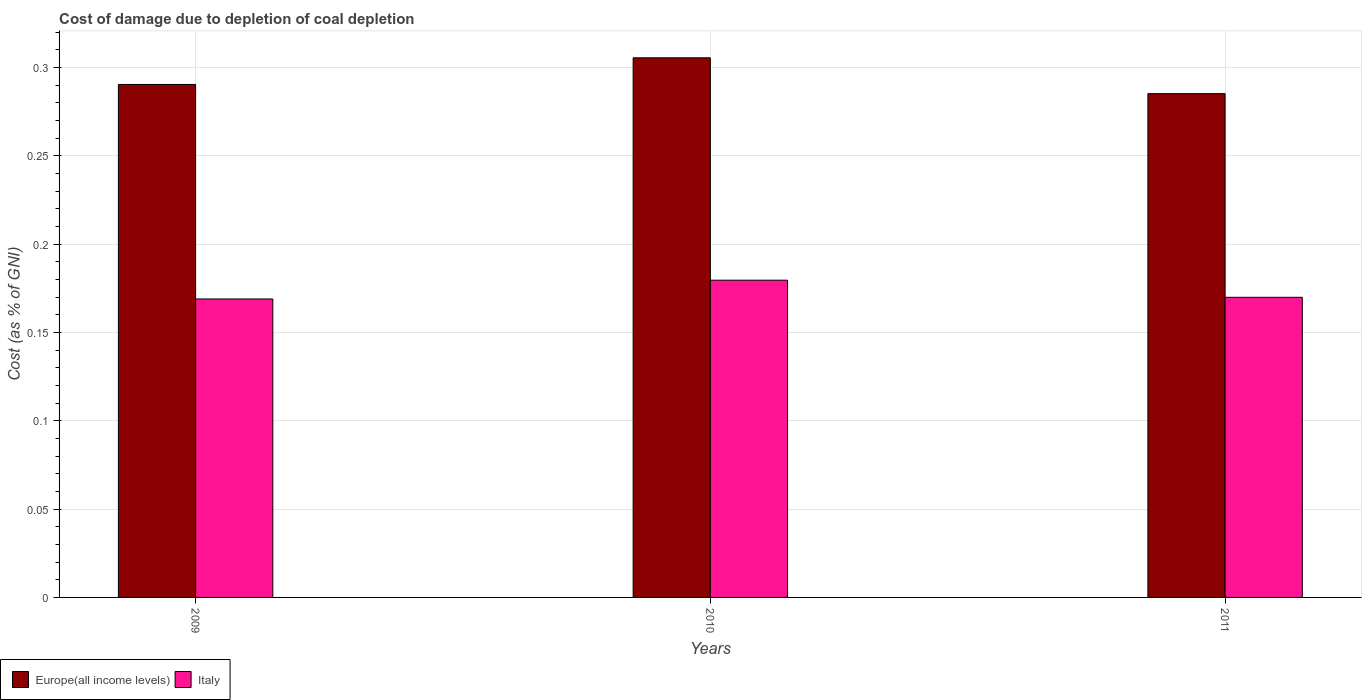How many different coloured bars are there?
Provide a succinct answer. 2. How many groups of bars are there?
Your answer should be very brief. 3. Are the number of bars on each tick of the X-axis equal?
Make the answer very short. Yes. How many bars are there on the 3rd tick from the left?
Offer a terse response. 2. What is the cost of damage caused due to coal depletion in Italy in 2011?
Your response must be concise. 0.17. Across all years, what is the maximum cost of damage caused due to coal depletion in Europe(all income levels)?
Offer a very short reply. 0.31. Across all years, what is the minimum cost of damage caused due to coal depletion in Europe(all income levels)?
Make the answer very short. 0.29. In which year was the cost of damage caused due to coal depletion in Europe(all income levels) minimum?
Your answer should be compact. 2011. What is the total cost of damage caused due to coal depletion in Europe(all income levels) in the graph?
Keep it short and to the point. 0.88. What is the difference between the cost of damage caused due to coal depletion in Europe(all income levels) in 2010 and that in 2011?
Your answer should be very brief. 0.02. What is the difference between the cost of damage caused due to coal depletion in Italy in 2010 and the cost of damage caused due to coal depletion in Europe(all income levels) in 2009?
Provide a succinct answer. -0.11. What is the average cost of damage caused due to coal depletion in Italy per year?
Provide a succinct answer. 0.17. In the year 2009, what is the difference between the cost of damage caused due to coal depletion in Italy and cost of damage caused due to coal depletion in Europe(all income levels)?
Keep it short and to the point. -0.12. What is the ratio of the cost of damage caused due to coal depletion in Italy in 2009 to that in 2010?
Provide a short and direct response. 0.94. What is the difference between the highest and the second highest cost of damage caused due to coal depletion in Europe(all income levels)?
Your answer should be very brief. 0.02. What is the difference between the highest and the lowest cost of damage caused due to coal depletion in Italy?
Make the answer very short. 0.01. In how many years, is the cost of damage caused due to coal depletion in Europe(all income levels) greater than the average cost of damage caused due to coal depletion in Europe(all income levels) taken over all years?
Give a very brief answer. 1. What does the 1st bar from the left in 2010 represents?
Give a very brief answer. Europe(all income levels). What does the 1st bar from the right in 2009 represents?
Your response must be concise. Italy. How many bars are there?
Offer a very short reply. 6. Are all the bars in the graph horizontal?
Give a very brief answer. No. How many years are there in the graph?
Offer a very short reply. 3. Does the graph contain grids?
Offer a very short reply. Yes. How many legend labels are there?
Make the answer very short. 2. How are the legend labels stacked?
Make the answer very short. Horizontal. What is the title of the graph?
Ensure brevity in your answer.  Cost of damage due to depletion of coal depletion. Does "Swaziland" appear as one of the legend labels in the graph?
Provide a succinct answer. No. What is the label or title of the X-axis?
Ensure brevity in your answer.  Years. What is the label or title of the Y-axis?
Your response must be concise. Cost (as % of GNI). What is the Cost (as % of GNI) of Europe(all income levels) in 2009?
Give a very brief answer. 0.29. What is the Cost (as % of GNI) in Italy in 2009?
Provide a short and direct response. 0.17. What is the Cost (as % of GNI) in Europe(all income levels) in 2010?
Your answer should be compact. 0.31. What is the Cost (as % of GNI) in Italy in 2010?
Provide a short and direct response. 0.18. What is the Cost (as % of GNI) in Europe(all income levels) in 2011?
Offer a terse response. 0.29. What is the Cost (as % of GNI) in Italy in 2011?
Offer a terse response. 0.17. Across all years, what is the maximum Cost (as % of GNI) in Europe(all income levels)?
Keep it short and to the point. 0.31. Across all years, what is the maximum Cost (as % of GNI) of Italy?
Your answer should be very brief. 0.18. Across all years, what is the minimum Cost (as % of GNI) of Europe(all income levels)?
Offer a terse response. 0.29. Across all years, what is the minimum Cost (as % of GNI) in Italy?
Make the answer very short. 0.17. What is the total Cost (as % of GNI) of Europe(all income levels) in the graph?
Your answer should be compact. 0.88. What is the total Cost (as % of GNI) of Italy in the graph?
Your response must be concise. 0.52. What is the difference between the Cost (as % of GNI) of Europe(all income levels) in 2009 and that in 2010?
Offer a terse response. -0.02. What is the difference between the Cost (as % of GNI) of Italy in 2009 and that in 2010?
Offer a terse response. -0.01. What is the difference between the Cost (as % of GNI) in Europe(all income levels) in 2009 and that in 2011?
Keep it short and to the point. 0.01. What is the difference between the Cost (as % of GNI) of Italy in 2009 and that in 2011?
Offer a terse response. -0. What is the difference between the Cost (as % of GNI) of Europe(all income levels) in 2010 and that in 2011?
Provide a short and direct response. 0.02. What is the difference between the Cost (as % of GNI) of Italy in 2010 and that in 2011?
Your response must be concise. 0.01. What is the difference between the Cost (as % of GNI) of Europe(all income levels) in 2009 and the Cost (as % of GNI) of Italy in 2010?
Offer a very short reply. 0.11. What is the difference between the Cost (as % of GNI) in Europe(all income levels) in 2009 and the Cost (as % of GNI) in Italy in 2011?
Keep it short and to the point. 0.12. What is the difference between the Cost (as % of GNI) of Europe(all income levels) in 2010 and the Cost (as % of GNI) of Italy in 2011?
Offer a very short reply. 0.14. What is the average Cost (as % of GNI) of Europe(all income levels) per year?
Provide a short and direct response. 0.29. What is the average Cost (as % of GNI) in Italy per year?
Make the answer very short. 0.17. In the year 2009, what is the difference between the Cost (as % of GNI) of Europe(all income levels) and Cost (as % of GNI) of Italy?
Provide a succinct answer. 0.12. In the year 2010, what is the difference between the Cost (as % of GNI) of Europe(all income levels) and Cost (as % of GNI) of Italy?
Make the answer very short. 0.13. In the year 2011, what is the difference between the Cost (as % of GNI) in Europe(all income levels) and Cost (as % of GNI) in Italy?
Make the answer very short. 0.12. What is the ratio of the Cost (as % of GNI) of Europe(all income levels) in 2009 to that in 2010?
Give a very brief answer. 0.95. What is the ratio of the Cost (as % of GNI) of Italy in 2009 to that in 2010?
Provide a succinct answer. 0.94. What is the ratio of the Cost (as % of GNI) in Europe(all income levels) in 2009 to that in 2011?
Ensure brevity in your answer.  1.02. What is the ratio of the Cost (as % of GNI) in Italy in 2009 to that in 2011?
Make the answer very short. 0.99. What is the ratio of the Cost (as % of GNI) in Europe(all income levels) in 2010 to that in 2011?
Your answer should be very brief. 1.07. What is the ratio of the Cost (as % of GNI) in Italy in 2010 to that in 2011?
Keep it short and to the point. 1.06. What is the difference between the highest and the second highest Cost (as % of GNI) of Europe(all income levels)?
Provide a short and direct response. 0.02. What is the difference between the highest and the second highest Cost (as % of GNI) of Italy?
Offer a very short reply. 0.01. What is the difference between the highest and the lowest Cost (as % of GNI) in Europe(all income levels)?
Offer a terse response. 0.02. What is the difference between the highest and the lowest Cost (as % of GNI) in Italy?
Your response must be concise. 0.01. 